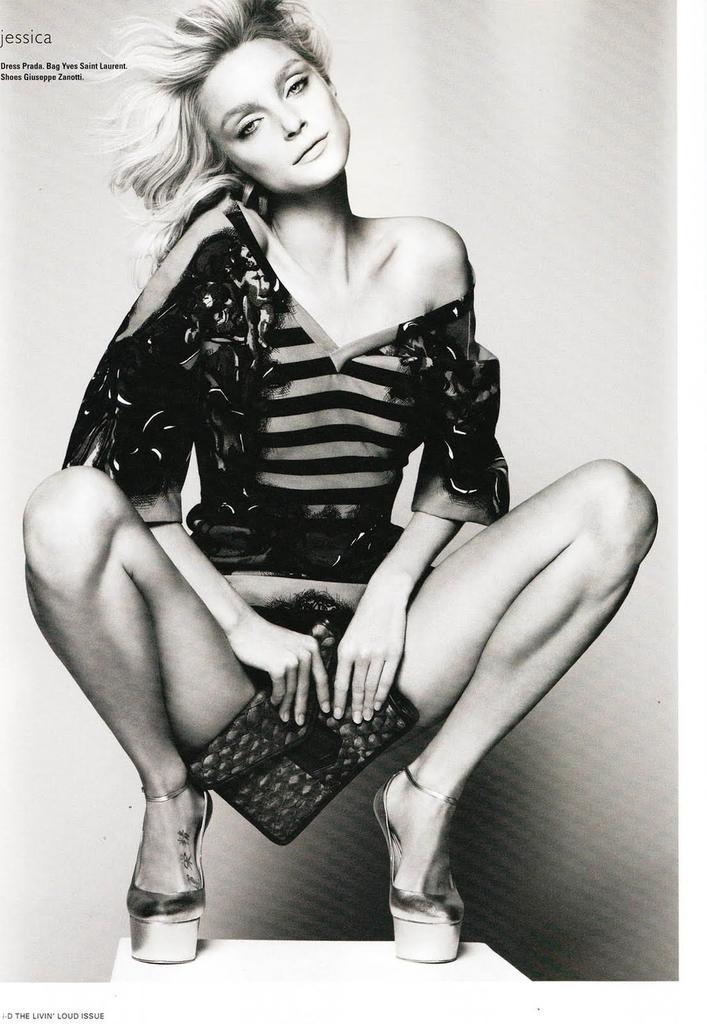Can you describe this image briefly? It is a black and white image. In this image, we can see a woman is holding a clutch and watching. On the left side of the image, we can see some text. 